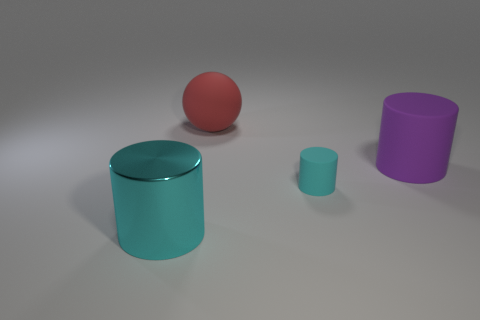Subtract all green cylinders. Subtract all blue balls. How many cylinders are left? 3 Add 2 metallic cylinders. How many objects exist? 6 Subtract all spheres. How many objects are left? 3 Subtract all big blue blocks. Subtract all big cyan metallic cylinders. How many objects are left? 3 Add 3 red objects. How many red objects are left? 4 Add 1 spheres. How many spheres exist? 2 Subtract 0 yellow balls. How many objects are left? 4 